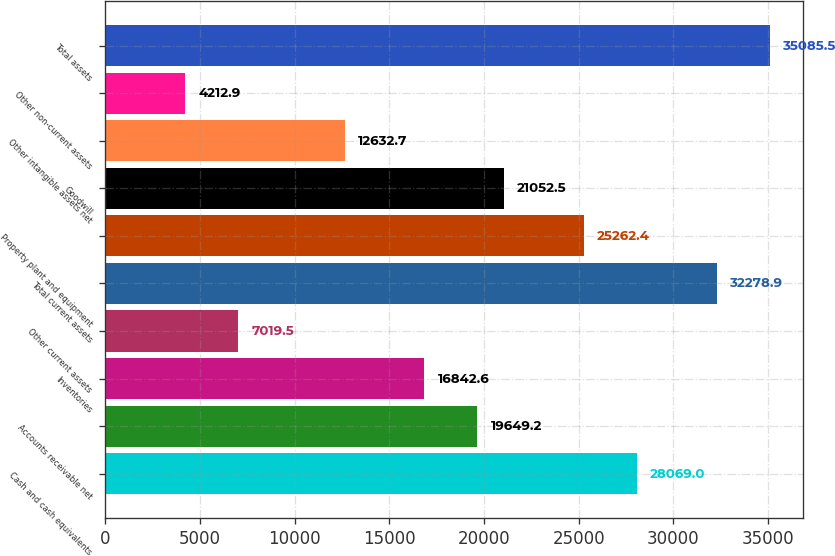Convert chart. <chart><loc_0><loc_0><loc_500><loc_500><bar_chart><fcel>Cash and cash equivalents<fcel>Accounts receivable net<fcel>Inventories<fcel>Other current assets<fcel>Total current assets<fcel>Property plant and equipment<fcel>Goodwill<fcel>Other intangible assets net<fcel>Other non-current assets<fcel>Total assets<nl><fcel>28069<fcel>19649.2<fcel>16842.6<fcel>7019.5<fcel>32278.9<fcel>25262.4<fcel>21052.5<fcel>12632.7<fcel>4212.9<fcel>35085.5<nl></chart> 